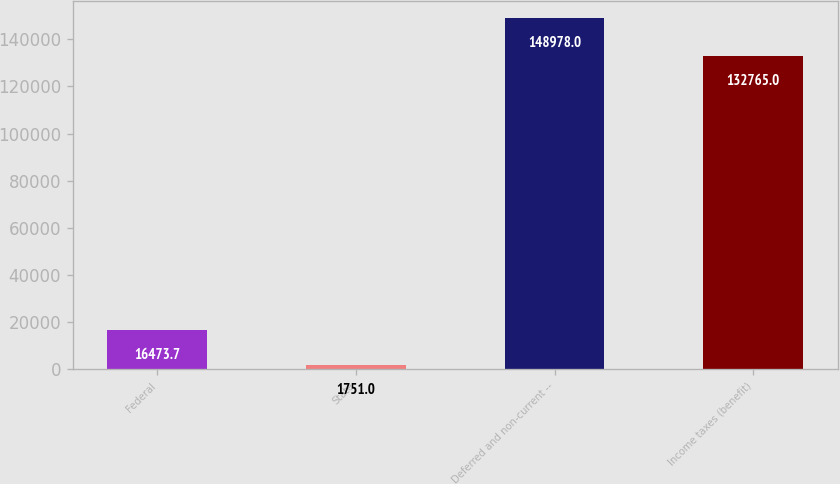Convert chart to OTSL. <chart><loc_0><loc_0><loc_500><loc_500><bar_chart><fcel>Federal<fcel>State<fcel>Deferred and non-current --<fcel>Income taxes (benefit)<nl><fcel>16473.7<fcel>1751<fcel>148978<fcel>132765<nl></chart> 